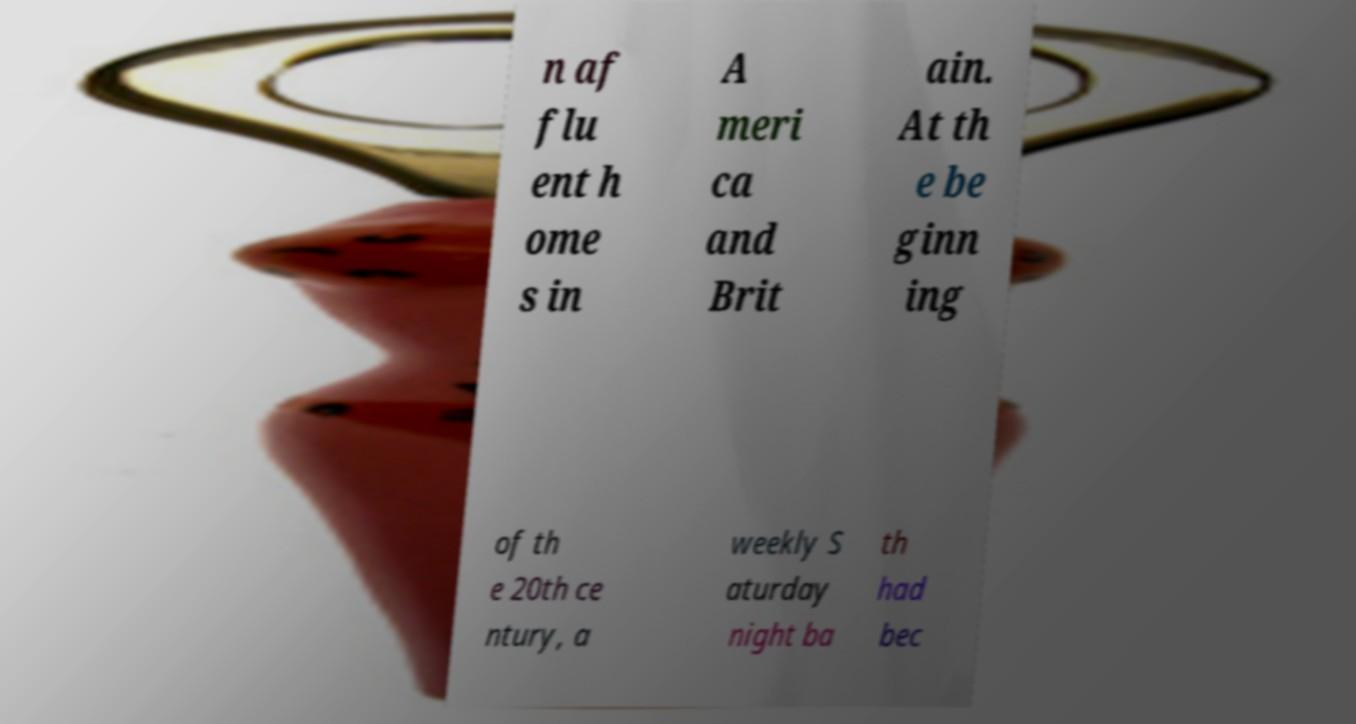Please read and relay the text visible in this image. What does it say? n af flu ent h ome s in A meri ca and Brit ain. At th e be ginn ing of th e 20th ce ntury, a weekly S aturday night ba th had bec 